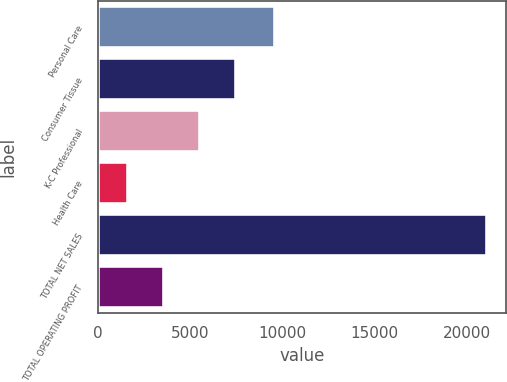Convert chart to OTSL. <chart><loc_0><loc_0><loc_500><loc_500><bar_chart><fcel>Personal Care<fcel>Consumer Tissue<fcel>K-C Professional<fcel>Health Care<fcel>TOTAL NET SALES<fcel>TOTAL OPERATING PROFIT<nl><fcel>9576<fcel>7454.3<fcel>5510.2<fcel>1622<fcel>21063<fcel>3566.1<nl></chart> 